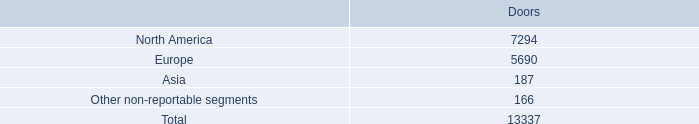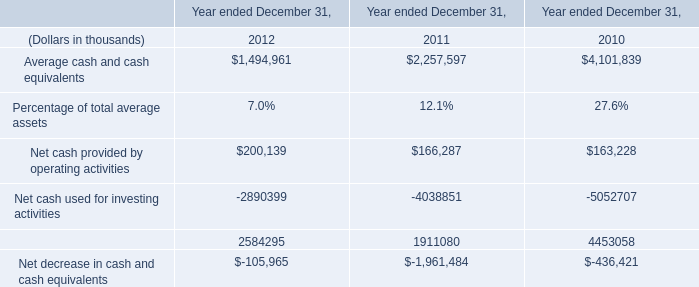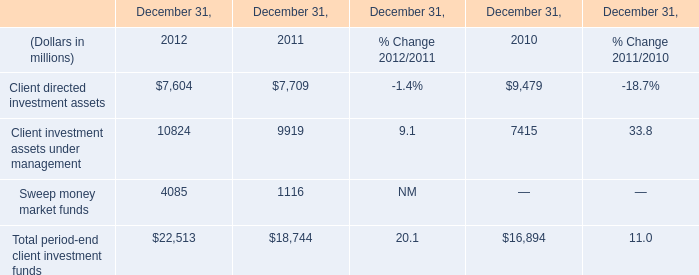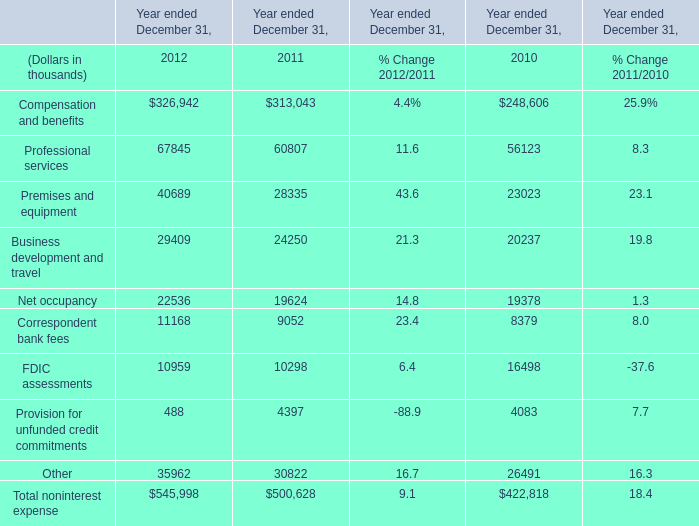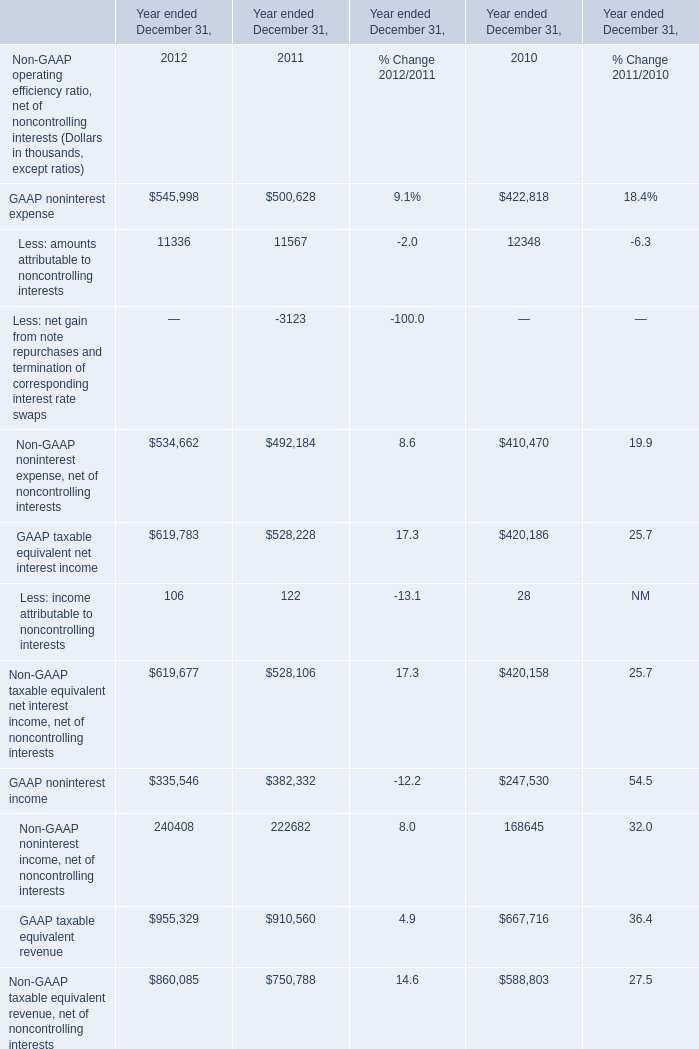What's the sum of Client directed investment assets of December 31, 2010, Net occupancy of Year ended December 31, 2011, and Client investment assets under management of December 31, 2011 ? 
Computations: ((9479.0 + 19624.0) + 9919.0)
Answer: 39022.0. 